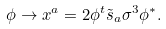<formula> <loc_0><loc_0><loc_500><loc_500>\phi \rightarrow x ^ { a } = 2 \phi ^ { t } \tilde { s } _ { a } \sigma ^ { 3 } \phi ^ { * } .</formula> 